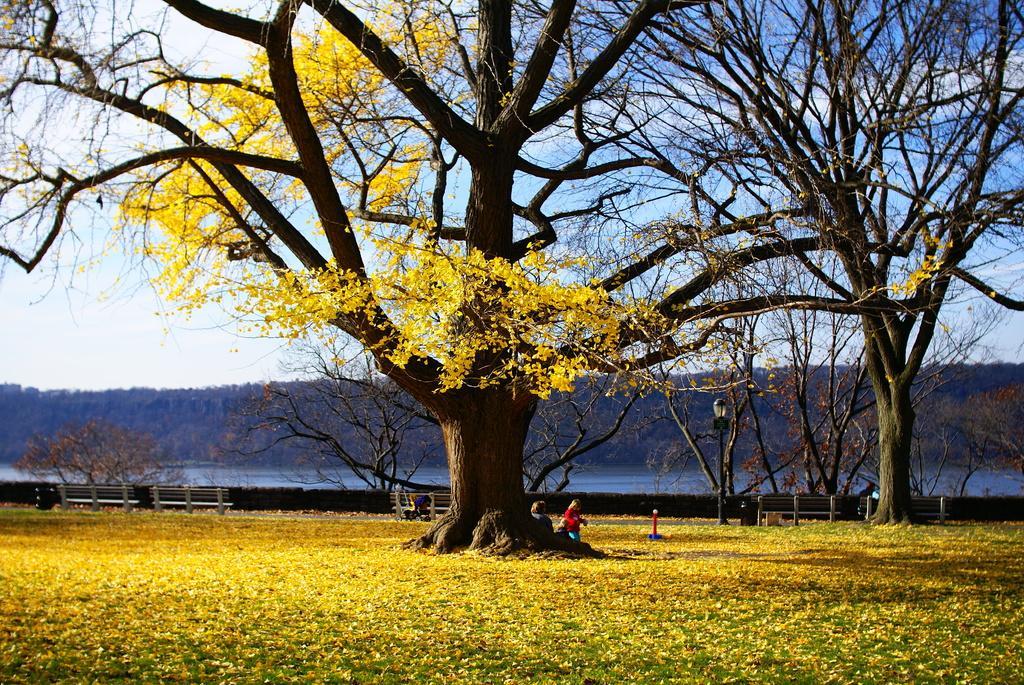Please provide a concise description of this image. In this image there are few persons are walking on the land having few leaves and grass. There are few benches. There are few trees on the land. There is a street light beside the bench. Behind there is a wall. Behind it there are few trees. Middle of image there is water, behind there is hill. Top of it there is sky. 